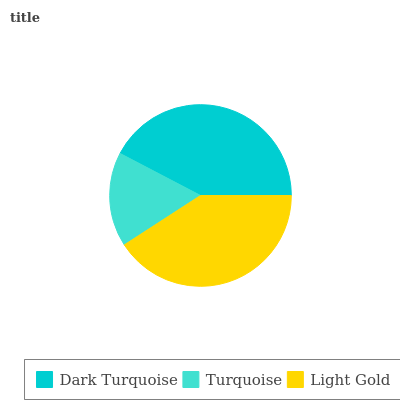Is Turquoise the minimum?
Answer yes or no. Yes. Is Dark Turquoise the maximum?
Answer yes or no. Yes. Is Light Gold the minimum?
Answer yes or no. No. Is Light Gold the maximum?
Answer yes or no. No. Is Light Gold greater than Turquoise?
Answer yes or no. Yes. Is Turquoise less than Light Gold?
Answer yes or no. Yes. Is Turquoise greater than Light Gold?
Answer yes or no. No. Is Light Gold less than Turquoise?
Answer yes or no. No. Is Light Gold the high median?
Answer yes or no. Yes. Is Light Gold the low median?
Answer yes or no. Yes. Is Dark Turquoise the high median?
Answer yes or no. No. Is Dark Turquoise the low median?
Answer yes or no. No. 